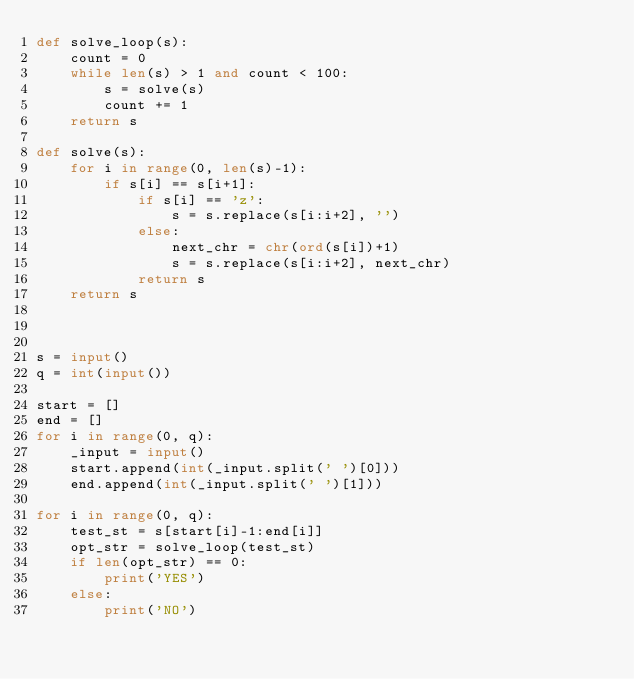Convert code to text. <code><loc_0><loc_0><loc_500><loc_500><_Python_>def solve_loop(s):
    count = 0
    while len(s) > 1 and count < 100:
        s = solve(s)
        count += 1
    return s

def solve(s):
    for i in range(0, len(s)-1):
        if s[i] == s[i+1]:
            if s[i] == 'z':
                s = s.replace(s[i:i+2], '')
            else:
                next_chr = chr(ord(s[i])+1)
                s = s.replace(s[i:i+2], next_chr)
            return s
    return s



s = input()
q = int(input())

start = []
end = []
for i in range(0, q):
    _input = input()
    start.append(int(_input.split(' ')[0]))
    end.append(int(_input.split(' ')[1]))

for i in range(0, q):
    test_st = s[start[i]-1:end[i]]
    opt_str = solve_loop(test_st)
    if len(opt_str) == 0:
        print('YES')
    else:
        print('NO')
</code> 